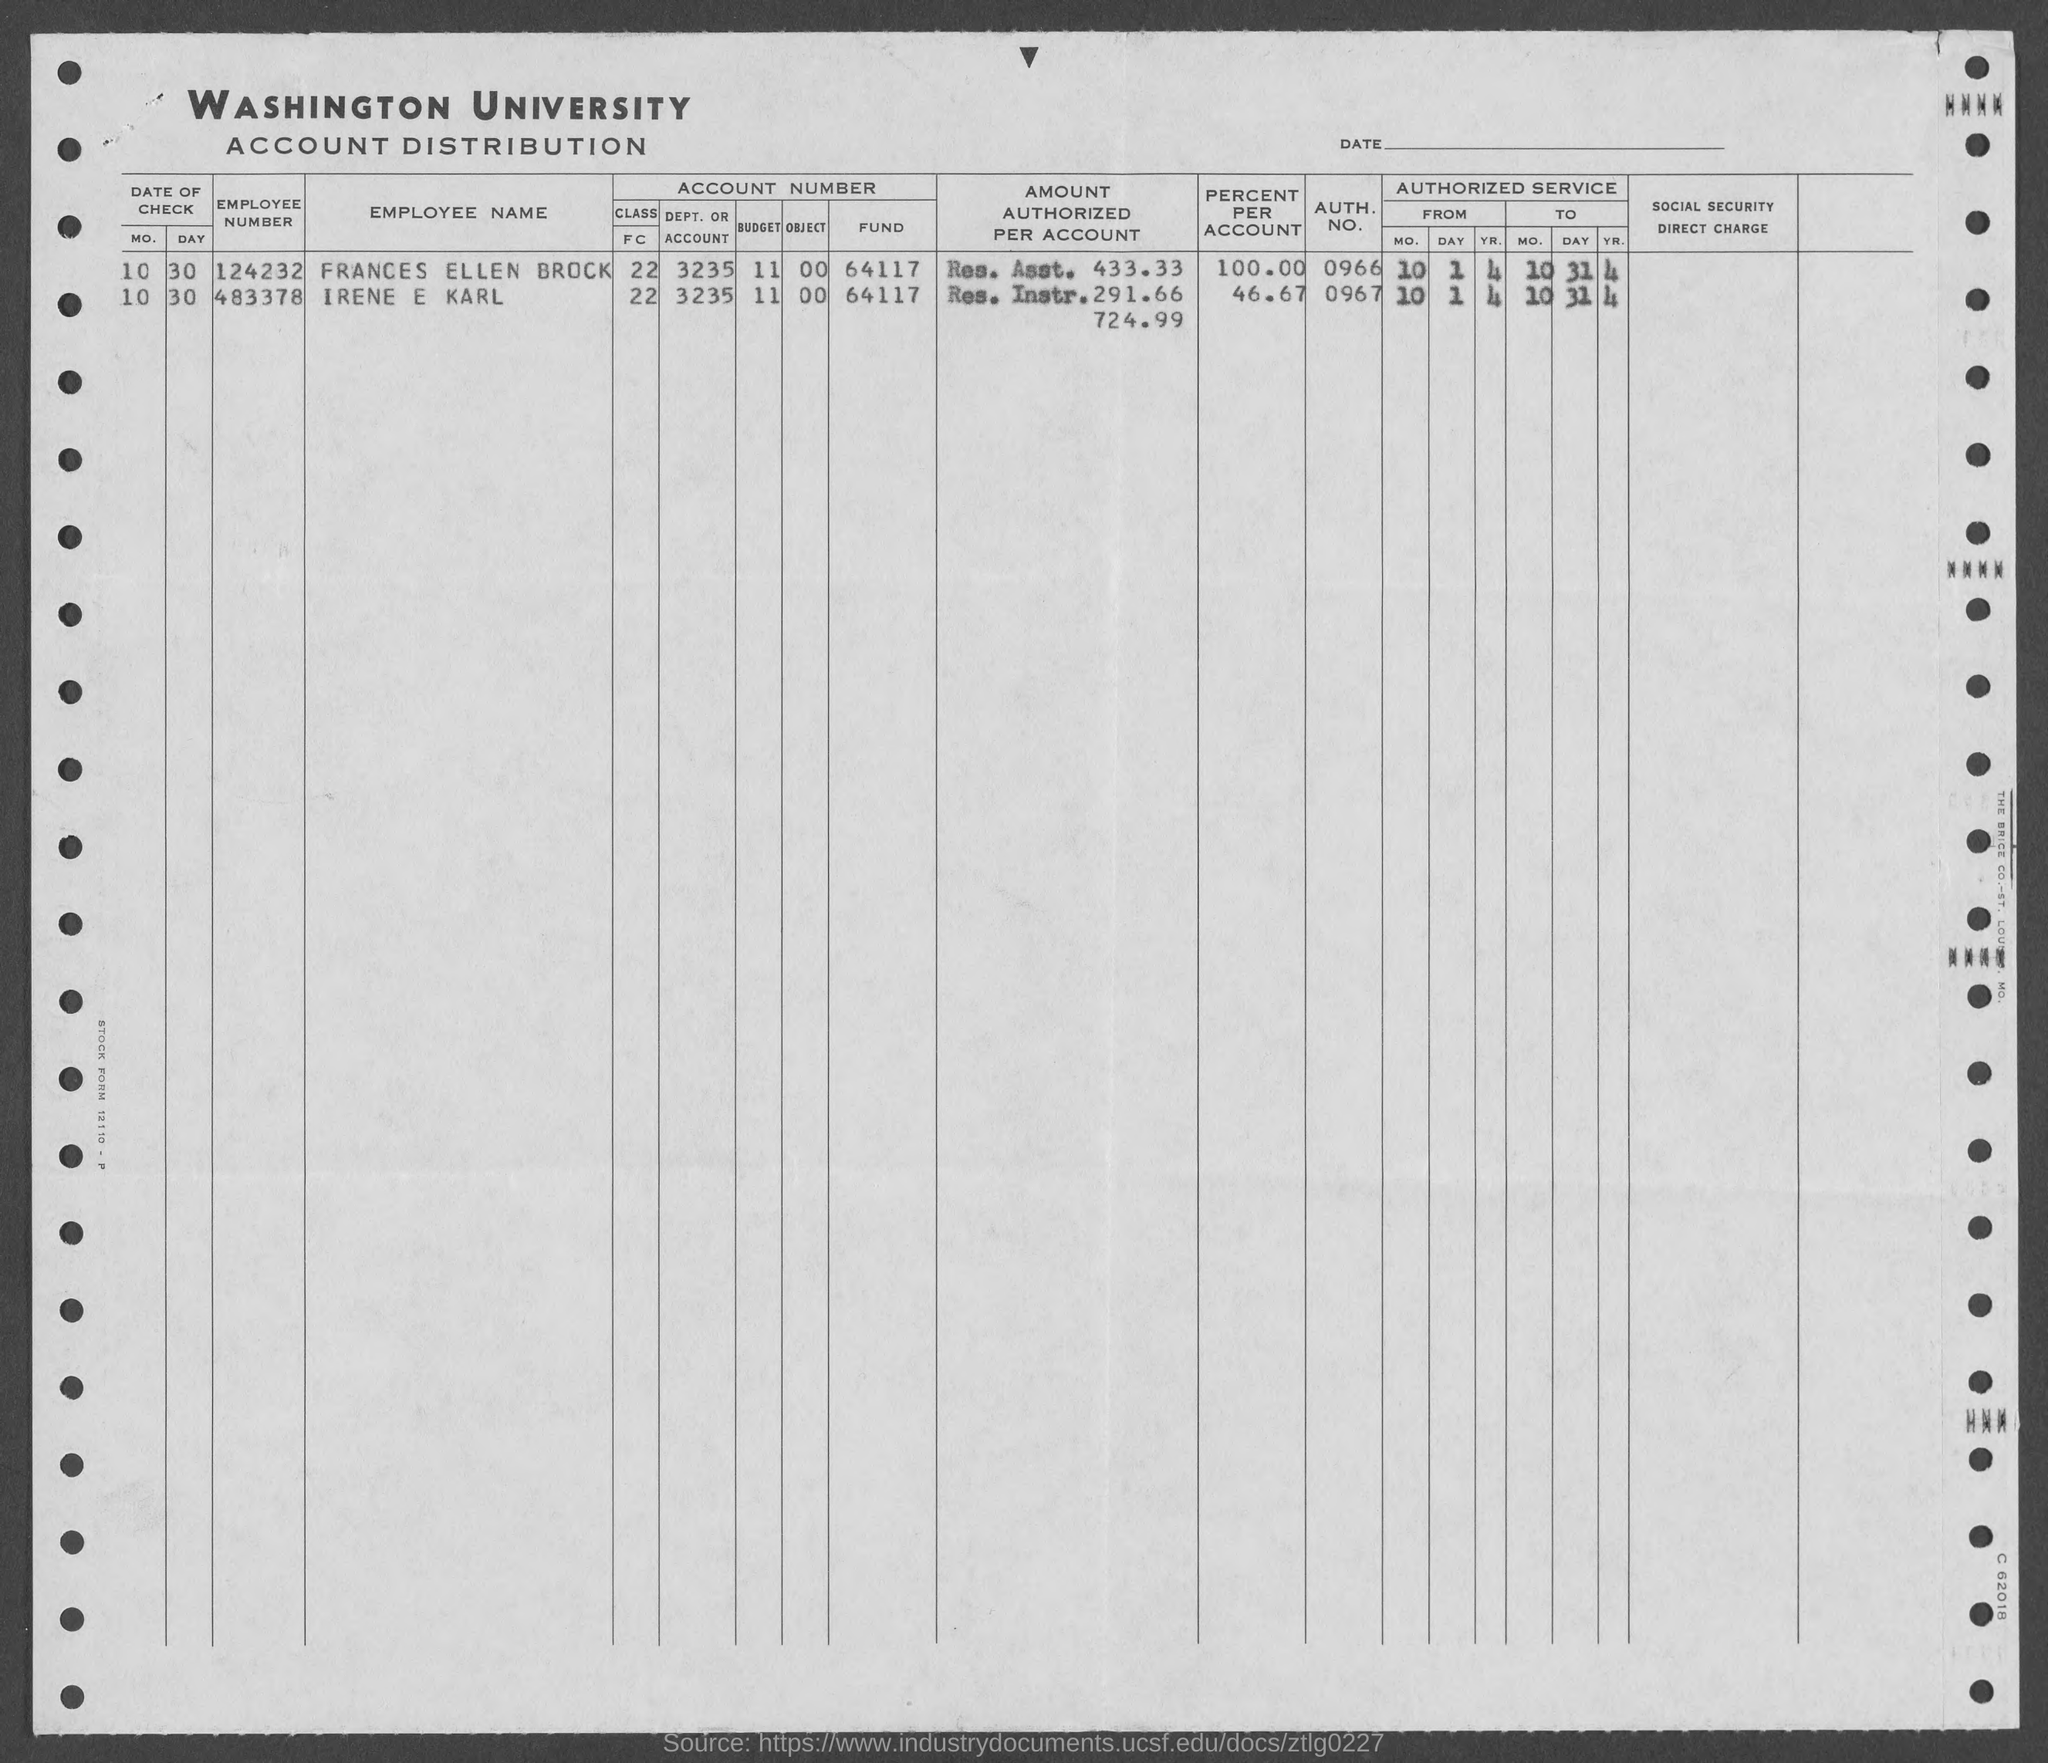what is the auth. no. for irene e karl ? The Authorization Number for Irene E Karl as seen on the Washington University Account Distribution document is 0967. 